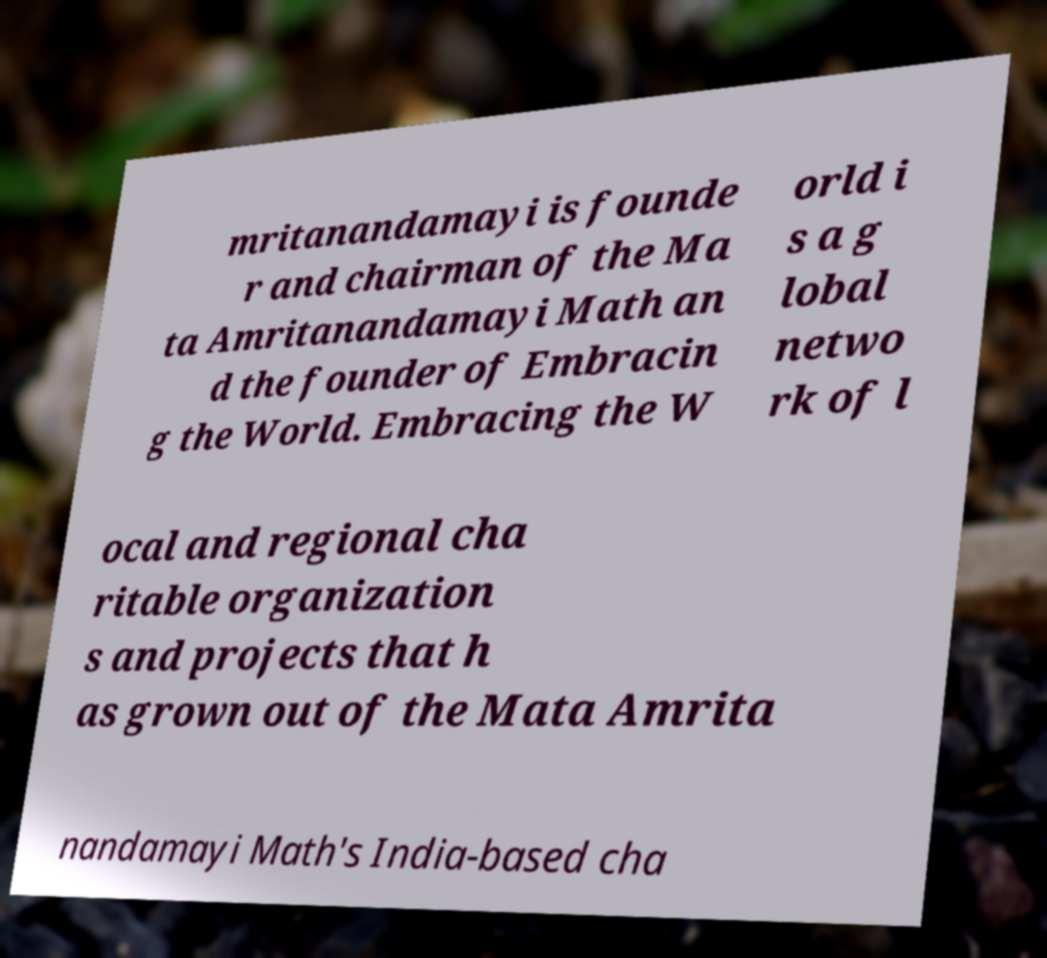Please identify and transcribe the text found in this image. mritanandamayi is founde r and chairman of the Ma ta Amritanandamayi Math an d the founder of Embracin g the World. Embracing the W orld i s a g lobal netwo rk of l ocal and regional cha ritable organization s and projects that h as grown out of the Mata Amrita nandamayi Math's India-based cha 